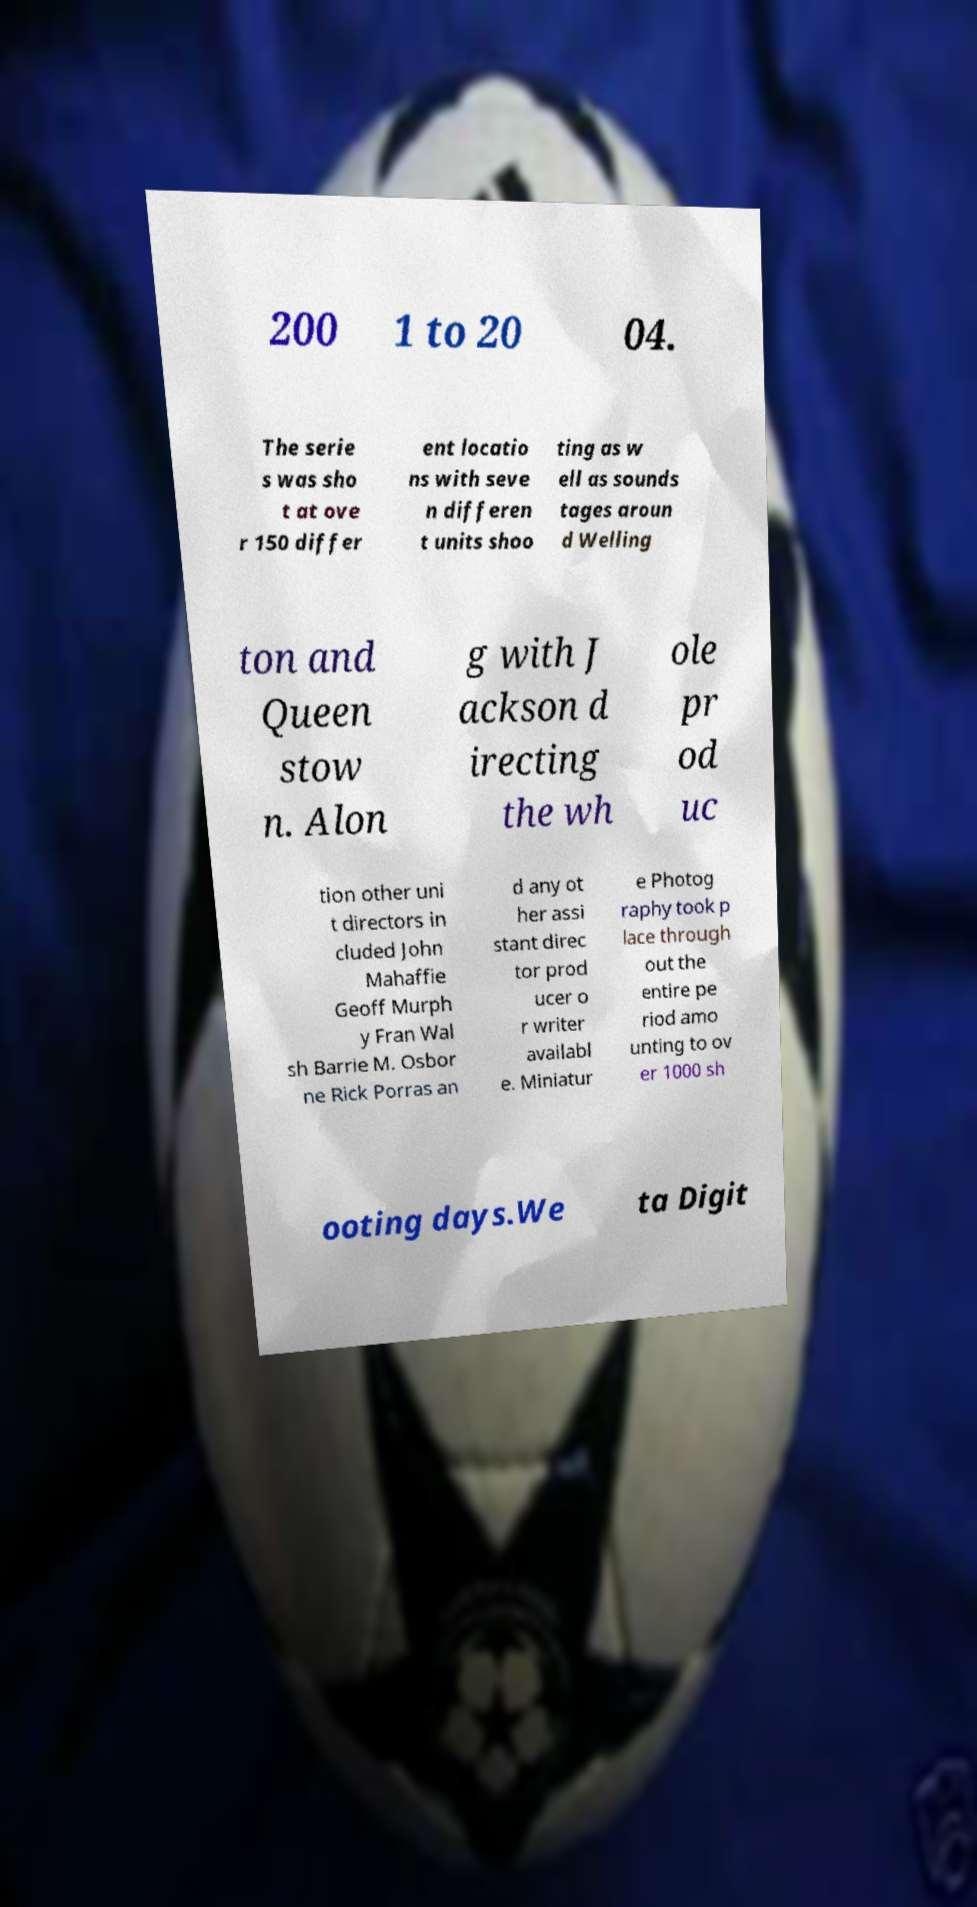Can you accurately transcribe the text from the provided image for me? 200 1 to 20 04. The serie s was sho t at ove r 150 differ ent locatio ns with seve n differen t units shoo ting as w ell as sounds tages aroun d Welling ton and Queen stow n. Alon g with J ackson d irecting the wh ole pr od uc tion other uni t directors in cluded John Mahaffie Geoff Murph y Fran Wal sh Barrie M. Osbor ne Rick Porras an d any ot her assi stant direc tor prod ucer o r writer availabl e. Miniatur e Photog raphy took p lace through out the entire pe riod amo unting to ov er 1000 sh ooting days.We ta Digit 